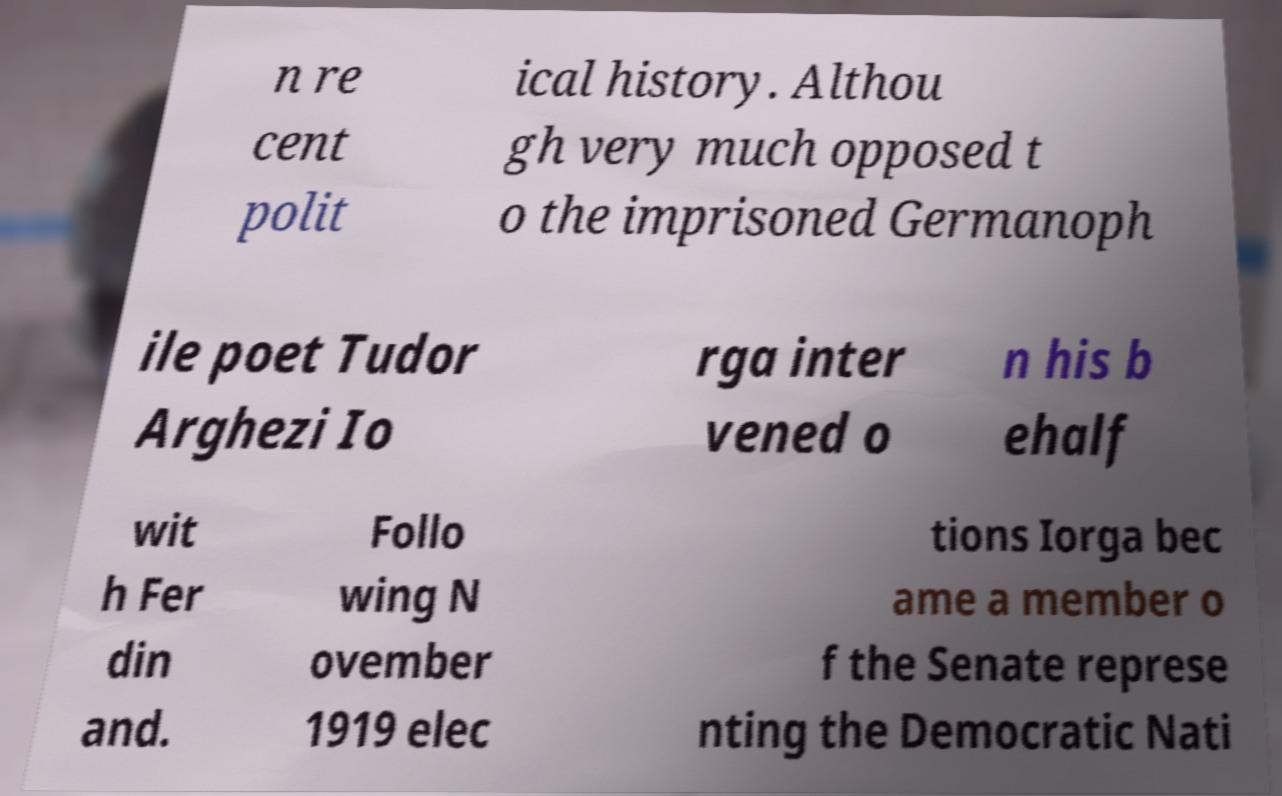Could you extract and type out the text from this image? n re cent polit ical history. Althou gh very much opposed t o the imprisoned Germanoph ile poet Tudor Arghezi Io rga inter vened o n his b ehalf wit h Fer din and. Follo wing N ovember 1919 elec tions Iorga bec ame a member o f the Senate represe nting the Democratic Nati 